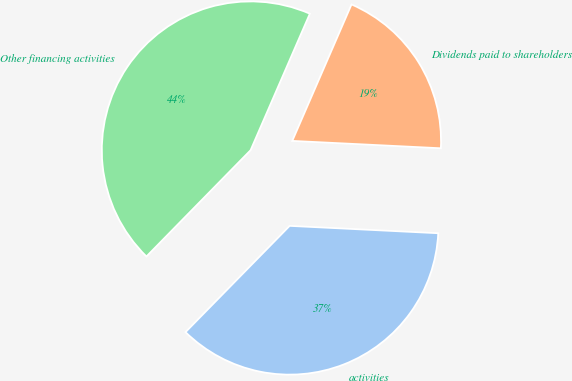<chart> <loc_0><loc_0><loc_500><loc_500><pie_chart><fcel>activities<fcel>Dividends paid to shareholders<fcel>Other financing activities<nl><fcel>36.55%<fcel>19.27%<fcel>44.18%<nl></chart> 